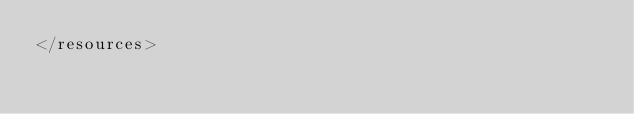<code> <loc_0><loc_0><loc_500><loc_500><_XML_></resources></code> 